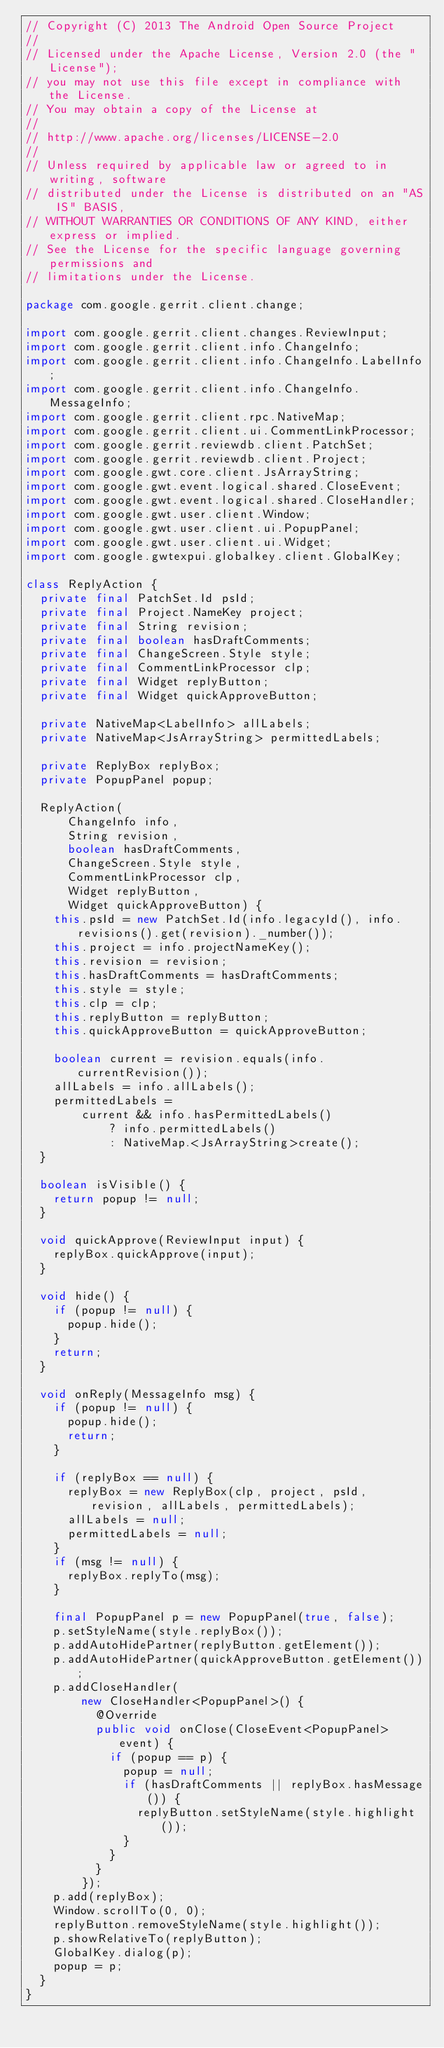<code> <loc_0><loc_0><loc_500><loc_500><_Java_>// Copyright (C) 2013 The Android Open Source Project
//
// Licensed under the Apache License, Version 2.0 (the "License");
// you may not use this file except in compliance with the License.
// You may obtain a copy of the License at
//
// http://www.apache.org/licenses/LICENSE-2.0
//
// Unless required by applicable law or agreed to in writing, software
// distributed under the License is distributed on an "AS IS" BASIS,
// WITHOUT WARRANTIES OR CONDITIONS OF ANY KIND, either express or implied.
// See the License for the specific language governing permissions and
// limitations under the License.

package com.google.gerrit.client.change;

import com.google.gerrit.client.changes.ReviewInput;
import com.google.gerrit.client.info.ChangeInfo;
import com.google.gerrit.client.info.ChangeInfo.LabelInfo;
import com.google.gerrit.client.info.ChangeInfo.MessageInfo;
import com.google.gerrit.client.rpc.NativeMap;
import com.google.gerrit.client.ui.CommentLinkProcessor;
import com.google.gerrit.reviewdb.client.PatchSet;
import com.google.gerrit.reviewdb.client.Project;
import com.google.gwt.core.client.JsArrayString;
import com.google.gwt.event.logical.shared.CloseEvent;
import com.google.gwt.event.logical.shared.CloseHandler;
import com.google.gwt.user.client.Window;
import com.google.gwt.user.client.ui.PopupPanel;
import com.google.gwt.user.client.ui.Widget;
import com.google.gwtexpui.globalkey.client.GlobalKey;

class ReplyAction {
  private final PatchSet.Id psId;
  private final Project.NameKey project;
  private final String revision;
  private final boolean hasDraftComments;
  private final ChangeScreen.Style style;
  private final CommentLinkProcessor clp;
  private final Widget replyButton;
  private final Widget quickApproveButton;

  private NativeMap<LabelInfo> allLabels;
  private NativeMap<JsArrayString> permittedLabels;

  private ReplyBox replyBox;
  private PopupPanel popup;

  ReplyAction(
      ChangeInfo info,
      String revision,
      boolean hasDraftComments,
      ChangeScreen.Style style,
      CommentLinkProcessor clp,
      Widget replyButton,
      Widget quickApproveButton) {
    this.psId = new PatchSet.Id(info.legacyId(), info.revisions().get(revision)._number());
    this.project = info.projectNameKey();
    this.revision = revision;
    this.hasDraftComments = hasDraftComments;
    this.style = style;
    this.clp = clp;
    this.replyButton = replyButton;
    this.quickApproveButton = quickApproveButton;

    boolean current = revision.equals(info.currentRevision());
    allLabels = info.allLabels();
    permittedLabels =
        current && info.hasPermittedLabels()
            ? info.permittedLabels()
            : NativeMap.<JsArrayString>create();
  }

  boolean isVisible() {
    return popup != null;
  }

  void quickApprove(ReviewInput input) {
    replyBox.quickApprove(input);
  }

  void hide() {
    if (popup != null) {
      popup.hide();
    }
    return;
  }

  void onReply(MessageInfo msg) {
    if (popup != null) {
      popup.hide();
      return;
    }

    if (replyBox == null) {
      replyBox = new ReplyBox(clp, project, psId, revision, allLabels, permittedLabels);
      allLabels = null;
      permittedLabels = null;
    }
    if (msg != null) {
      replyBox.replyTo(msg);
    }

    final PopupPanel p = new PopupPanel(true, false);
    p.setStyleName(style.replyBox());
    p.addAutoHidePartner(replyButton.getElement());
    p.addAutoHidePartner(quickApproveButton.getElement());
    p.addCloseHandler(
        new CloseHandler<PopupPanel>() {
          @Override
          public void onClose(CloseEvent<PopupPanel> event) {
            if (popup == p) {
              popup = null;
              if (hasDraftComments || replyBox.hasMessage()) {
                replyButton.setStyleName(style.highlight());
              }
            }
          }
        });
    p.add(replyBox);
    Window.scrollTo(0, 0);
    replyButton.removeStyleName(style.highlight());
    p.showRelativeTo(replyButton);
    GlobalKey.dialog(p);
    popup = p;
  }
}
</code> 